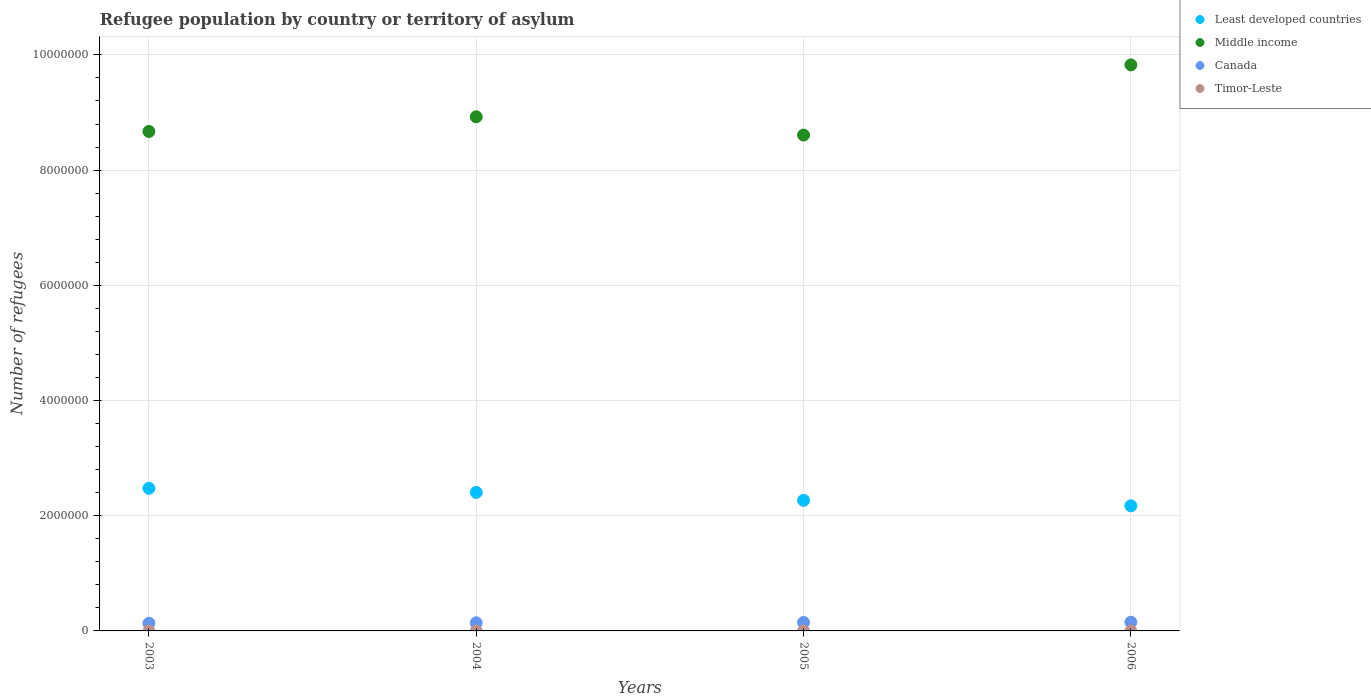How many different coloured dotlines are there?
Provide a succinct answer. 4. Is the number of dotlines equal to the number of legend labels?
Your response must be concise. Yes. What is the number of refugees in Least developed countries in 2003?
Offer a terse response. 2.48e+06. Across all years, what is the maximum number of refugees in Least developed countries?
Provide a short and direct response. 2.48e+06. Across all years, what is the minimum number of refugees in Canada?
Ensure brevity in your answer.  1.33e+05. In which year was the number of refugees in Timor-Leste maximum?
Provide a succinct answer. 2003. In which year was the number of refugees in Least developed countries minimum?
Provide a succinct answer. 2006. What is the total number of refugees in Middle income in the graph?
Provide a short and direct response. 3.60e+07. What is the difference between the number of refugees in Least developed countries in 2006 and the number of refugees in Timor-Leste in 2004?
Your response must be concise. 2.17e+06. What is the average number of refugees in Middle income per year?
Make the answer very short. 9.01e+06. In the year 2003, what is the difference between the number of refugees in Timor-Leste and number of refugees in Least developed countries?
Make the answer very short. -2.48e+06. Is the number of refugees in Middle income in 2005 less than that in 2006?
Offer a very short reply. Yes. What is the difference between the highest and the second highest number of refugees in Middle income?
Offer a terse response. 9.02e+05. What is the difference between the highest and the lowest number of refugees in Middle income?
Provide a succinct answer. 1.22e+06. In how many years, is the number of refugees in Timor-Leste greater than the average number of refugees in Timor-Leste taken over all years?
Keep it short and to the point. 0. Is the sum of the number of refugees in Middle income in 2004 and 2006 greater than the maximum number of refugees in Least developed countries across all years?
Provide a succinct answer. Yes. Is it the case that in every year, the sum of the number of refugees in Middle income and number of refugees in Canada  is greater than the number of refugees in Least developed countries?
Keep it short and to the point. Yes. Does the number of refugees in Middle income monotonically increase over the years?
Keep it short and to the point. No. Is the number of refugees in Middle income strictly less than the number of refugees in Canada over the years?
Ensure brevity in your answer.  No. Does the graph contain any zero values?
Make the answer very short. No. Does the graph contain grids?
Your response must be concise. Yes. How many legend labels are there?
Offer a terse response. 4. How are the legend labels stacked?
Keep it short and to the point. Vertical. What is the title of the graph?
Offer a terse response. Refugee population by country or territory of asylum. What is the label or title of the Y-axis?
Keep it short and to the point. Number of refugees. What is the Number of refugees of Least developed countries in 2003?
Your response must be concise. 2.48e+06. What is the Number of refugees in Middle income in 2003?
Your answer should be very brief. 8.67e+06. What is the Number of refugees in Canada in 2003?
Offer a very short reply. 1.33e+05. What is the Number of refugees in Timor-Leste in 2003?
Provide a succinct answer. 3. What is the Number of refugees in Least developed countries in 2004?
Your answer should be compact. 2.40e+06. What is the Number of refugees of Middle income in 2004?
Provide a short and direct response. 8.93e+06. What is the Number of refugees in Canada in 2004?
Provide a short and direct response. 1.41e+05. What is the Number of refugees of Least developed countries in 2005?
Your answer should be compact. 2.27e+06. What is the Number of refugees of Middle income in 2005?
Keep it short and to the point. 8.61e+06. What is the Number of refugees of Canada in 2005?
Keep it short and to the point. 1.47e+05. What is the Number of refugees in Least developed countries in 2006?
Provide a succinct answer. 2.17e+06. What is the Number of refugees in Middle income in 2006?
Your response must be concise. 9.83e+06. What is the Number of refugees of Canada in 2006?
Keep it short and to the point. 1.52e+05. What is the Number of refugees in Timor-Leste in 2006?
Offer a very short reply. 3. Across all years, what is the maximum Number of refugees in Least developed countries?
Provide a succinct answer. 2.48e+06. Across all years, what is the maximum Number of refugees of Middle income?
Offer a very short reply. 9.83e+06. Across all years, what is the maximum Number of refugees in Canada?
Your response must be concise. 1.52e+05. Across all years, what is the maximum Number of refugees of Timor-Leste?
Ensure brevity in your answer.  3. Across all years, what is the minimum Number of refugees in Least developed countries?
Make the answer very short. 2.17e+06. Across all years, what is the minimum Number of refugees in Middle income?
Give a very brief answer. 8.61e+06. Across all years, what is the minimum Number of refugees of Canada?
Your answer should be very brief. 1.33e+05. What is the total Number of refugees of Least developed countries in the graph?
Your answer should be very brief. 9.32e+06. What is the total Number of refugees in Middle income in the graph?
Your answer should be very brief. 3.60e+07. What is the total Number of refugees in Canada in the graph?
Provide a succinct answer. 5.73e+05. What is the difference between the Number of refugees of Least developed countries in 2003 and that in 2004?
Ensure brevity in your answer.  7.16e+04. What is the difference between the Number of refugees in Middle income in 2003 and that in 2004?
Your response must be concise. -2.55e+05. What is the difference between the Number of refugees of Canada in 2003 and that in 2004?
Offer a terse response. -8304. What is the difference between the Number of refugees of Timor-Leste in 2003 and that in 2004?
Provide a short and direct response. 0. What is the difference between the Number of refugees of Least developed countries in 2003 and that in 2005?
Give a very brief answer. 2.09e+05. What is the difference between the Number of refugees of Middle income in 2003 and that in 2005?
Your answer should be very brief. 6.20e+04. What is the difference between the Number of refugees of Canada in 2003 and that in 2005?
Your answer should be very brief. -1.41e+04. What is the difference between the Number of refugees in Least developed countries in 2003 and that in 2006?
Offer a very short reply. 3.05e+05. What is the difference between the Number of refugees in Middle income in 2003 and that in 2006?
Keep it short and to the point. -1.16e+06. What is the difference between the Number of refugees of Canada in 2003 and that in 2006?
Give a very brief answer. -1.87e+04. What is the difference between the Number of refugees of Least developed countries in 2004 and that in 2005?
Provide a short and direct response. 1.38e+05. What is the difference between the Number of refugees of Middle income in 2004 and that in 2005?
Keep it short and to the point. 3.17e+05. What is the difference between the Number of refugees of Canada in 2004 and that in 2005?
Offer a terse response. -5773. What is the difference between the Number of refugees in Timor-Leste in 2004 and that in 2005?
Make the answer very short. 0. What is the difference between the Number of refugees of Least developed countries in 2004 and that in 2006?
Provide a succinct answer. 2.33e+05. What is the difference between the Number of refugees of Middle income in 2004 and that in 2006?
Provide a succinct answer. -9.02e+05. What is the difference between the Number of refugees of Canada in 2004 and that in 2006?
Offer a very short reply. -1.04e+04. What is the difference between the Number of refugees in Timor-Leste in 2004 and that in 2006?
Ensure brevity in your answer.  0. What is the difference between the Number of refugees of Least developed countries in 2005 and that in 2006?
Make the answer very short. 9.52e+04. What is the difference between the Number of refugees in Middle income in 2005 and that in 2006?
Offer a terse response. -1.22e+06. What is the difference between the Number of refugees of Canada in 2005 and that in 2006?
Provide a succinct answer. -4656. What is the difference between the Number of refugees of Timor-Leste in 2005 and that in 2006?
Make the answer very short. 0. What is the difference between the Number of refugees of Least developed countries in 2003 and the Number of refugees of Middle income in 2004?
Your answer should be compact. -6.45e+06. What is the difference between the Number of refugees in Least developed countries in 2003 and the Number of refugees in Canada in 2004?
Make the answer very short. 2.33e+06. What is the difference between the Number of refugees of Least developed countries in 2003 and the Number of refugees of Timor-Leste in 2004?
Give a very brief answer. 2.48e+06. What is the difference between the Number of refugees in Middle income in 2003 and the Number of refugees in Canada in 2004?
Your answer should be compact. 8.53e+06. What is the difference between the Number of refugees in Middle income in 2003 and the Number of refugees in Timor-Leste in 2004?
Your answer should be very brief. 8.67e+06. What is the difference between the Number of refugees in Canada in 2003 and the Number of refugees in Timor-Leste in 2004?
Your answer should be very brief. 1.33e+05. What is the difference between the Number of refugees in Least developed countries in 2003 and the Number of refugees in Middle income in 2005?
Give a very brief answer. -6.13e+06. What is the difference between the Number of refugees in Least developed countries in 2003 and the Number of refugees in Canada in 2005?
Ensure brevity in your answer.  2.33e+06. What is the difference between the Number of refugees of Least developed countries in 2003 and the Number of refugees of Timor-Leste in 2005?
Keep it short and to the point. 2.48e+06. What is the difference between the Number of refugees of Middle income in 2003 and the Number of refugees of Canada in 2005?
Offer a terse response. 8.52e+06. What is the difference between the Number of refugees in Middle income in 2003 and the Number of refugees in Timor-Leste in 2005?
Provide a succinct answer. 8.67e+06. What is the difference between the Number of refugees of Canada in 2003 and the Number of refugees of Timor-Leste in 2005?
Your answer should be very brief. 1.33e+05. What is the difference between the Number of refugees in Least developed countries in 2003 and the Number of refugees in Middle income in 2006?
Provide a short and direct response. -7.35e+06. What is the difference between the Number of refugees of Least developed countries in 2003 and the Number of refugees of Canada in 2006?
Offer a very short reply. 2.32e+06. What is the difference between the Number of refugees in Least developed countries in 2003 and the Number of refugees in Timor-Leste in 2006?
Your answer should be compact. 2.48e+06. What is the difference between the Number of refugees of Middle income in 2003 and the Number of refugees of Canada in 2006?
Your response must be concise. 8.52e+06. What is the difference between the Number of refugees of Middle income in 2003 and the Number of refugees of Timor-Leste in 2006?
Give a very brief answer. 8.67e+06. What is the difference between the Number of refugees of Canada in 2003 and the Number of refugees of Timor-Leste in 2006?
Ensure brevity in your answer.  1.33e+05. What is the difference between the Number of refugees in Least developed countries in 2004 and the Number of refugees in Middle income in 2005?
Your answer should be very brief. -6.20e+06. What is the difference between the Number of refugees in Least developed countries in 2004 and the Number of refugees in Canada in 2005?
Ensure brevity in your answer.  2.26e+06. What is the difference between the Number of refugees in Least developed countries in 2004 and the Number of refugees in Timor-Leste in 2005?
Make the answer very short. 2.40e+06. What is the difference between the Number of refugees of Middle income in 2004 and the Number of refugees of Canada in 2005?
Provide a short and direct response. 8.78e+06. What is the difference between the Number of refugees of Middle income in 2004 and the Number of refugees of Timor-Leste in 2005?
Offer a terse response. 8.93e+06. What is the difference between the Number of refugees of Canada in 2004 and the Number of refugees of Timor-Leste in 2005?
Make the answer very short. 1.41e+05. What is the difference between the Number of refugees of Least developed countries in 2004 and the Number of refugees of Middle income in 2006?
Ensure brevity in your answer.  -7.42e+06. What is the difference between the Number of refugees of Least developed countries in 2004 and the Number of refugees of Canada in 2006?
Provide a succinct answer. 2.25e+06. What is the difference between the Number of refugees in Least developed countries in 2004 and the Number of refugees in Timor-Leste in 2006?
Make the answer very short. 2.40e+06. What is the difference between the Number of refugees of Middle income in 2004 and the Number of refugees of Canada in 2006?
Keep it short and to the point. 8.77e+06. What is the difference between the Number of refugees of Middle income in 2004 and the Number of refugees of Timor-Leste in 2006?
Offer a terse response. 8.93e+06. What is the difference between the Number of refugees in Canada in 2004 and the Number of refugees in Timor-Leste in 2006?
Offer a terse response. 1.41e+05. What is the difference between the Number of refugees in Least developed countries in 2005 and the Number of refugees in Middle income in 2006?
Offer a very short reply. -7.56e+06. What is the difference between the Number of refugees of Least developed countries in 2005 and the Number of refugees of Canada in 2006?
Your answer should be compact. 2.12e+06. What is the difference between the Number of refugees of Least developed countries in 2005 and the Number of refugees of Timor-Leste in 2006?
Your response must be concise. 2.27e+06. What is the difference between the Number of refugees in Middle income in 2005 and the Number of refugees in Canada in 2006?
Provide a succinct answer. 8.46e+06. What is the difference between the Number of refugees in Middle income in 2005 and the Number of refugees in Timor-Leste in 2006?
Make the answer very short. 8.61e+06. What is the difference between the Number of refugees in Canada in 2005 and the Number of refugees in Timor-Leste in 2006?
Your answer should be compact. 1.47e+05. What is the average Number of refugees of Least developed countries per year?
Offer a very short reply. 2.33e+06. What is the average Number of refugees of Middle income per year?
Your answer should be very brief. 9.01e+06. What is the average Number of refugees of Canada per year?
Make the answer very short. 1.43e+05. What is the average Number of refugees in Timor-Leste per year?
Your answer should be compact. 3. In the year 2003, what is the difference between the Number of refugees of Least developed countries and Number of refugees of Middle income?
Your response must be concise. -6.19e+06. In the year 2003, what is the difference between the Number of refugees of Least developed countries and Number of refugees of Canada?
Provide a short and direct response. 2.34e+06. In the year 2003, what is the difference between the Number of refugees in Least developed countries and Number of refugees in Timor-Leste?
Your answer should be compact. 2.48e+06. In the year 2003, what is the difference between the Number of refugees of Middle income and Number of refugees of Canada?
Your response must be concise. 8.54e+06. In the year 2003, what is the difference between the Number of refugees in Middle income and Number of refugees in Timor-Leste?
Provide a succinct answer. 8.67e+06. In the year 2003, what is the difference between the Number of refugees of Canada and Number of refugees of Timor-Leste?
Give a very brief answer. 1.33e+05. In the year 2004, what is the difference between the Number of refugees in Least developed countries and Number of refugees in Middle income?
Ensure brevity in your answer.  -6.52e+06. In the year 2004, what is the difference between the Number of refugees of Least developed countries and Number of refugees of Canada?
Your answer should be compact. 2.26e+06. In the year 2004, what is the difference between the Number of refugees in Least developed countries and Number of refugees in Timor-Leste?
Provide a short and direct response. 2.40e+06. In the year 2004, what is the difference between the Number of refugees of Middle income and Number of refugees of Canada?
Ensure brevity in your answer.  8.78e+06. In the year 2004, what is the difference between the Number of refugees of Middle income and Number of refugees of Timor-Leste?
Ensure brevity in your answer.  8.93e+06. In the year 2004, what is the difference between the Number of refugees of Canada and Number of refugees of Timor-Leste?
Offer a terse response. 1.41e+05. In the year 2005, what is the difference between the Number of refugees of Least developed countries and Number of refugees of Middle income?
Your response must be concise. -6.34e+06. In the year 2005, what is the difference between the Number of refugees in Least developed countries and Number of refugees in Canada?
Give a very brief answer. 2.12e+06. In the year 2005, what is the difference between the Number of refugees of Least developed countries and Number of refugees of Timor-Leste?
Provide a succinct answer. 2.27e+06. In the year 2005, what is the difference between the Number of refugees in Middle income and Number of refugees in Canada?
Provide a succinct answer. 8.46e+06. In the year 2005, what is the difference between the Number of refugees in Middle income and Number of refugees in Timor-Leste?
Give a very brief answer. 8.61e+06. In the year 2005, what is the difference between the Number of refugees in Canada and Number of refugees in Timor-Leste?
Provide a succinct answer. 1.47e+05. In the year 2006, what is the difference between the Number of refugees of Least developed countries and Number of refugees of Middle income?
Your answer should be very brief. -7.66e+06. In the year 2006, what is the difference between the Number of refugees of Least developed countries and Number of refugees of Canada?
Offer a terse response. 2.02e+06. In the year 2006, what is the difference between the Number of refugees in Least developed countries and Number of refugees in Timor-Leste?
Your response must be concise. 2.17e+06. In the year 2006, what is the difference between the Number of refugees of Middle income and Number of refugees of Canada?
Provide a succinct answer. 9.67e+06. In the year 2006, what is the difference between the Number of refugees of Middle income and Number of refugees of Timor-Leste?
Keep it short and to the point. 9.83e+06. In the year 2006, what is the difference between the Number of refugees in Canada and Number of refugees in Timor-Leste?
Offer a terse response. 1.52e+05. What is the ratio of the Number of refugees of Least developed countries in 2003 to that in 2004?
Your answer should be very brief. 1.03. What is the ratio of the Number of refugees in Middle income in 2003 to that in 2004?
Provide a succinct answer. 0.97. What is the ratio of the Number of refugees of Canada in 2003 to that in 2004?
Ensure brevity in your answer.  0.94. What is the ratio of the Number of refugees in Least developed countries in 2003 to that in 2005?
Provide a succinct answer. 1.09. What is the ratio of the Number of refugees of Middle income in 2003 to that in 2005?
Your answer should be very brief. 1.01. What is the ratio of the Number of refugees of Canada in 2003 to that in 2005?
Provide a short and direct response. 0.9. What is the ratio of the Number of refugees of Least developed countries in 2003 to that in 2006?
Your response must be concise. 1.14. What is the ratio of the Number of refugees in Middle income in 2003 to that in 2006?
Your response must be concise. 0.88. What is the ratio of the Number of refugees in Canada in 2003 to that in 2006?
Provide a short and direct response. 0.88. What is the ratio of the Number of refugees in Least developed countries in 2004 to that in 2005?
Your response must be concise. 1.06. What is the ratio of the Number of refugees in Middle income in 2004 to that in 2005?
Provide a succinct answer. 1.04. What is the ratio of the Number of refugees in Canada in 2004 to that in 2005?
Offer a very short reply. 0.96. What is the ratio of the Number of refugees of Timor-Leste in 2004 to that in 2005?
Ensure brevity in your answer.  1. What is the ratio of the Number of refugees in Least developed countries in 2004 to that in 2006?
Make the answer very short. 1.11. What is the ratio of the Number of refugees in Middle income in 2004 to that in 2006?
Give a very brief answer. 0.91. What is the ratio of the Number of refugees of Canada in 2004 to that in 2006?
Provide a succinct answer. 0.93. What is the ratio of the Number of refugees of Least developed countries in 2005 to that in 2006?
Provide a short and direct response. 1.04. What is the ratio of the Number of refugees in Middle income in 2005 to that in 2006?
Provide a short and direct response. 0.88. What is the ratio of the Number of refugees in Canada in 2005 to that in 2006?
Give a very brief answer. 0.97. What is the ratio of the Number of refugees of Timor-Leste in 2005 to that in 2006?
Provide a succinct answer. 1. What is the difference between the highest and the second highest Number of refugees of Least developed countries?
Your response must be concise. 7.16e+04. What is the difference between the highest and the second highest Number of refugees in Middle income?
Your answer should be compact. 9.02e+05. What is the difference between the highest and the second highest Number of refugees in Canada?
Your response must be concise. 4656. What is the difference between the highest and the lowest Number of refugees of Least developed countries?
Your response must be concise. 3.05e+05. What is the difference between the highest and the lowest Number of refugees in Middle income?
Your response must be concise. 1.22e+06. What is the difference between the highest and the lowest Number of refugees in Canada?
Provide a short and direct response. 1.87e+04. What is the difference between the highest and the lowest Number of refugees in Timor-Leste?
Provide a short and direct response. 0. 